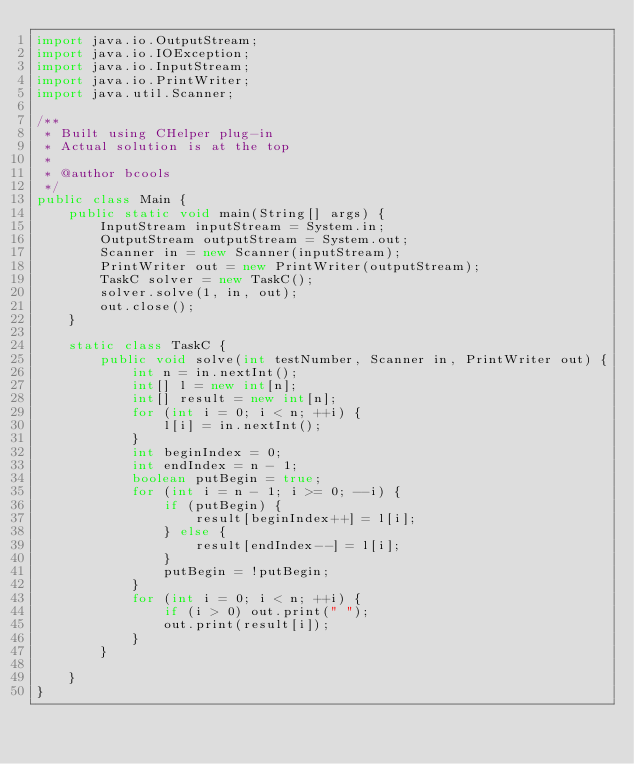<code> <loc_0><loc_0><loc_500><loc_500><_Java_>import java.io.OutputStream;
import java.io.IOException;
import java.io.InputStream;
import java.io.PrintWriter;
import java.util.Scanner;

/**
 * Built using CHelper plug-in
 * Actual solution is at the top
 *
 * @author bcools
 */
public class Main {
    public static void main(String[] args) {
        InputStream inputStream = System.in;
        OutputStream outputStream = System.out;
        Scanner in = new Scanner(inputStream);
        PrintWriter out = new PrintWriter(outputStream);
        TaskC solver = new TaskC();
        solver.solve(1, in, out);
        out.close();
    }

    static class TaskC {
        public void solve(int testNumber, Scanner in, PrintWriter out) {
            int n = in.nextInt();
            int[] l = new int[n];
            int[] result = new int[n];
            for (int i = 0; i < n; ++i) {
                l[i] = in.nextInt();
            }
            int beginIndex = 0;
            int endIndex = n - 1;
            boolean putBegin = true;
            for (int i = n - 1; i >= 0; --i) {
                if (putBegin) {
                    result[beginIndex++] = l[i];
                } else {
                    result[endIndex--] = l[i];
                }
                putBegin = !putBegin;
            }
            for (int i = 0; i < n; ++i) {
                if (i > 0) out.print(" ");
                out.print(result[i]);
            }
        }

    }
}

</code> 